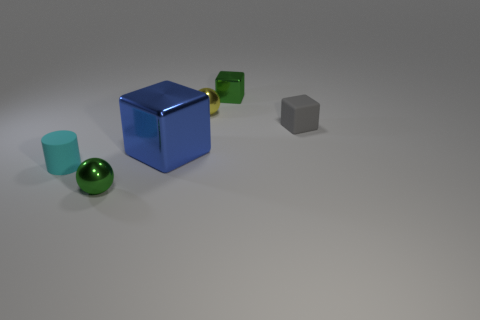Add 1 yellow objects. How many objects exist? 7 Subtract all green blocks. How many blocks are left? 2 Subtract all balls. How many objects are left? 4 Add 6 metal things. How many metal things exist? 10 Subtract 0 gray spheres. How many objects are left? 6 Subtract all big brown objects. Subtract all green shiny balls. How many objects are left? 5 Add 2 blocks. How many blocks are left? 5 